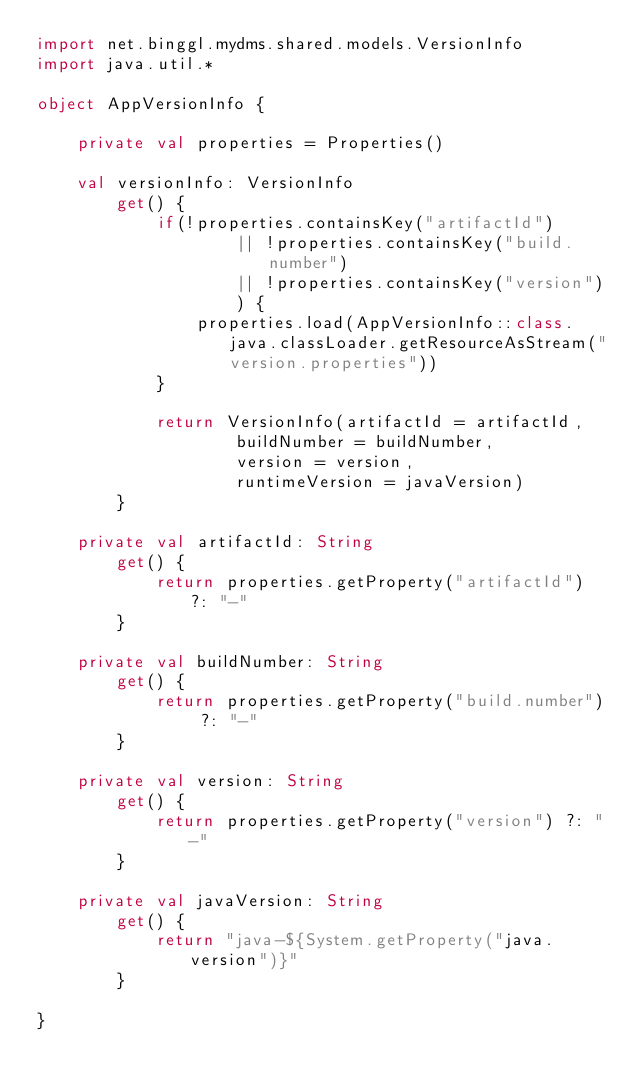<code> <loc_0><loc_0><loc_500><loc_500><_Kotlin_>import net.binggl.mydms.shared.models.VersionInfo
import java.util.*

object AppVersionInfo {

    private val properties = Properties()

    val versionInfo: VersionInfo
        get() {
            if(!properties.containsKey("artifactId")
                    || !properties.containsKey("build.number")
                    || !properties.containsKey("version")
                    ) {
                properties.load(AppVersionInfo::class.java.classLoader.getResourceAsStream("version.properties"))
            }

            return VersionInfo(artifactId = artifactId,
                    buildNumber = buildNumber,
                    version = version,
                    runtimeVersion = javaVersion)
        }

    private val artifactId: String
        get() {
            return properties.getProperty("artifactId") ?: "-"
        }

    private val buildNumber: String
        get() {
            return properties.getProperty("build.number") ?: "-"
        }

    private val version: String
        get() {
            return properties.getProperty("version") ?: "-"
        }

    private val javaVersion: String
        get() {
            return "java-${System.getProperty("java.version")}"
        }

}</code> 